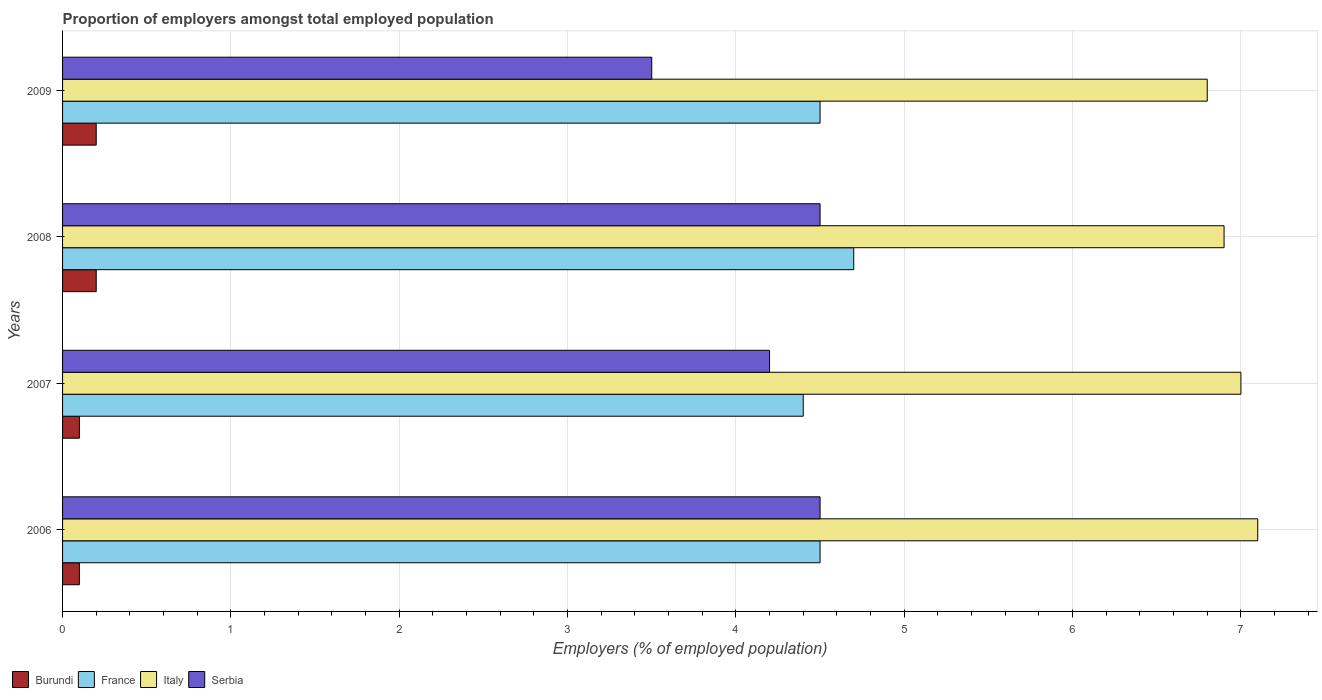Are the number of bars on each tick of the Y-axis equal?
Give a very brief answer. Yes. How many bars are there on the 2nd tick from the top?
Ensure brevity in your answer.  4. What is the label of the 2nd group of bars from the top?
Offer a terse response. 2008. What is the proportion of employers in Italy in 2009?
Your response must be concise. 6.8. Across all years, what is the maximum proportion of employers in Italy?
Ensure brevity in your answer.  7.1. Across all years, what is the minimum proportion of employers in Burundi?
Your response must be concise. 0.1. In which year was the proportion of employers in Burundi minimum?
Offer a very short reply. 2006. What is the total proportion of employers in Burundi in the graph?
Offer a terse response. 0.6. What is the difference between the proportion of employers in Burundi in 2007 and that in 2008?
Provide a short and direct response. -0.1. What is the difference between the proportion of employers in Italy in 2006 and the proportion of employers in Serbia in 2007?
Offer a terse response. 2.9. What is the average proportion of employers in Italy per year?
Offer a very short reply. 6.95. In the year 2007, what is the difference between the proportion of employers in France and proportion of employers in Italy?
Offer a very short reply. -2.6. In how many years, is the proportion of employers in Serbia greater than 0.6000000000000001 %?
Offer a terse response. 4. What is the ratio of the proportion of employers in Serbia in 2007 to that in 2009?
Your answer should be compact. 1.2. Is the proportion of employers in France in 2006 less than that in 2008?
Give a very brief answer. Yes. What is the difference between the highest and the second highest proportion of employers in France?
Offer a very short reply. 0.2. What is the difference between the highest and the lowest proportion of employers in Serbia?
Offer a terse response. 1. Is it the case that in every year, the sum of the proportion of employers in Serbia and proportion of employers in Burundi is greater than the sum of proportion of employers in France and proportion of employers in Italy?
Provide a short and direct response. No. What does the 4th bar from the top in 2008 represents?
Offer a terse response. Burundi. What does the 2nd bar from the bottom in 2007 represents?
Give a very brief answer. France. How many bars are there?
Provide a short and direct response. 16. Are all the bars in the graph horizontal?
Make the answer very short. Yes. How many years are there in the graph?
Offer a terse response. 4. Are the values on the major ticks of X-axis written in scientific E-notation?
Make the answer very short. No. How many legend labels are there?
Offer a very short reply. 4. What is the title of the graph?
Your response must be concise. Proportion of employers amongst total employed population. What is the label or title of the X-axis?
Give a very brief answer. Employers (% of employed population). What is the Employers (% of employed population) in Burundi in 2006?
Your answer should be very brief. 0.1. What is the Employers (% of employed population) of Italy in 2006?
Provide a short and direct response. 7.1. What is the Employers (% of employed population) in Serbia in 2006?
Give a very brief answer. 4.5. What is the Employers (% of employed population) in Burundi in 2007?
Your response must be concise. 0.1. What is the Employers (% of employed population) in France in 2007?
Your answer should be compact. 4.4. What is the Employers (% of employed population) in Serbia in 2007?
Your response must be concise. 4.2. What is the Employers (% of employed population) of Burundi in 2008?
Make the answer very short. 0.2. What is the Employers (% of employed population) in France in 2008?
Keep it short and to the point. 4.7. What is the Employers (% of employed population) of Italy in 2008?
Your response must be concise. 6.9. What is the Employers (% of employed population) in Burundi in 2009?
Provide a short and direct response. 0.2. What is the Employers (% of employed population) in Italy in 2009?
Give a very brief answer. 6.8. Across all years, what is the maximum Employers (% of employed population) of Burundi?
Ensure brevity in your answer.  0.2. Across all years, what is the maximum Employers (% of employed population) in France?
Provide a short and direct response. 4.7. Across all years, what is the maximum Employers (% of employed population) in Italy?
Your answer should be very brief. 7.1. Across all years, what is the maximum Employers (% of employed population) of Serbia?
Make the answer very short. 4.5. Across all years, what is the minimum Employers (% of employed population) in Burundi?
Your answer should be compact. 0.1. Across all years, what is the minimum Employers (% of employed population) in France?
Offer a very short reply. 4.4. Across all years, what is the minimum Employers (% of employed population) of Italy?
Keep it short and to the point. 6.8. What is the total Employers (% of employed population) of Burundi in the graph?
Provide a short and direct response. 0.6. What is the total Employers (% of employed population) in Italy in the graph?
Your answer should be compact. 27.8. What is the difference between the Employers (% of employed population) of Burundi in 2006 and that in 2007?
Make the answer very short. 0. What is the difference between the Employers (% of employed population) in Italy in 2006 and that in 2007?
Give a very brief answer. 0.1. What is the difference between the Employers (% of employed population) of Serbia in 2006 and that in 2007?
Provide a short and direct response. 0.3. What is the difference between the Employers (% of employed population) in France in 2006 and that in 2008?
Make the answer very short. -0.2. What is the difference between the Employers (% of employed population) of Serbia in 2006 and that in 2008?
Ensure brevity in your answer.  0. What is the difference between the Employers (% of employed population) of France in 2006 and that in 2009?
Offer a very short reply. 0. What is the difference between the Employers (% of employed population) in Italy in 2006 and that in 2009?
Your answer should be very brief. 0.3. What is the difference between the Employers (% of employed population) of Serbia in 2006 and that in 2009?
Make the answer very short. 1. What is the difference between the Employers (% of employed population) in Burundi in 2007 and that in 2008?
Keep it short and to the point. -0.1. What is the difference between the Employers (% of employed population) in Italy in 2007 and that in 2008?
Your answer should be very brief. 0.1. What is the difference between the Employers (% of employed population) in Serbia in 2007 and that in 2008?
Your answer should be very brief. -0.3. What is the difference between the Employers (% of employed population) in Serbia in 2008 and that in 2009?
Offer a terse response. 1. What is the difference between the Employers (% of employed population) of France in 2006 and the Employers (% of employed population) of Italy in 2007?
Provide a succinct answer. -2.5. What is the difference between the Employers (% of employed population) of Italy in 2006 and the Employers (% of employed population) of Serbia in 2007?
Provide a short and direct response. 2.9. What is the difference between the Employers (% of employed population) in Burundi in 2006 and the Employers (% of employed population) in France in 2008?
Provide a succinct answer. -4.6. What is the difference between the Employers (% of employed population) of Italy in 2006 and the Employers (% of employed population) of Serbia in 2008?
Your answer should be very brief. 2.6. What is the difference between the Employers (% of employed population) in Burundi in 2006 and the Employers (% of employed population) in France in 2009?
Your answer should be very brief. -4.4. What is the difference between the Employers (% of employed population) in Burundi in 2006 and the Employers (% of employed population) in Serbia in 2009?
Give a very brief answer. -3.4. What is the difference between the Employers (% of employed population) of France in 2006 and the Employers (% of employed population) of Serbia in 2009?
Make the answer very short. 1. What is the difference between the Employers (% of employed population) of France in 2007 and the Employers (% of employed population) of Serbia in 2008?
Provide a short and direct response. -0.1. What is the difference between the Employers (% of employed population) in Burundi in 2007 and the Employers (% of employed population) in France in 2009?
Offer a terse response. -4.4. What is the difference between the Employers (% of employed population) in France in 2007 and the Employers (% of employed population) in Serbia in 2009?
Ensure brevity in your answer.  0.9. What is the average Employers (% of employed population) in Burundi per year?
Your answer should be compact. 0.15. What is the average Employers (% of employed population) of France per year?
Provide a short and direct response. 4.53. What is the average Employers (% of employed population) in Italy per year?
Offer a very short reply. 6.95. What is the average Employers (% of employed population) of Serbia per year?
Ensure brevity in your answer.  4.17. In the year 2006, what is the difference between the Employers (% of employed population) of Burundi and Employers (% of employed population) of France?
Your answer should be compact. -4.4. In the year 2006, what is the difference between the Employers (% of employed population) of Burundi and Employers (% of employed population) of Italy?
Make the answer very short. -7. In the year 2006, what is the difference between the Employers (% of employed population) in Burundi and Employers (% of employed population) in Serbia?
Keep it short and to the point. -4.4. In the year 2006, what is the difference between the Employers (% of employed population) of France and Employers (% of employed population) of Italy?
Your response must be concise. -2.6. In the year 2006, what is the difference between the Employers (% of employed population) of France and Employers (% of employed population) of Serbia?
Provide a succinct answer. 0. In the year 2006, what is the difference between the Employers (% of employed population) in Italy and Employers (% of employed population) in Serbia?
Provide a succinct answer. 2.6. In the year 2007, what is the difference between the Employers (% of employed population) in Burundi and Employers (% of employed population) in Italy?
Give a very brief answer. -6.9. In the year 2007, what is the difference between the Employers (% of employed population) in Burundi and Employers (% of employed population) in Serbia?
Offer a very short reply. -4.1. In the year 2007, what is the difference between the Employers (% of employed population) of Italy and Employers (% of employed population) of Serbia?
Your response must be concise. 2.8. In the year 2008, what is the difference between the Employers (% of employed population) of Burundi and Employers (% of employed population) of France?
Keep it short and to the point. -4.5. In the year 2008, what is the difference between the Employers (% of employed population) of Burundi and Employers (% of employed population) of Italy?
Offer a terse response. -6.7. In the year 2008, what is the difference between the Employers (% of employed population) in Burundi and Employers (% of employed population) in Serbia?
Your answer should be very brief. -4.3. In the year 2008, what is the difference between the Employers (% of employed population) of France and Employers (% of employed population) of Italy?
Provide a short and direct response. -2.2. In the year 2009, what is the difference between the Employers (% of employed population) of Burundi and Employers (% of employed population) of Serbia?
Your response must be concise. -3.3. In the year 2009, what is the difference between the Employers (% of employed population) of France and Employers (% of employed population) of Serbia?
Offer a terse response. 1. What is the ratio of the Employers (% of employed population) in Burundi in 2006 to that in 2007?
Give a very brief answer. 1. What is the ratio of the Employers (% of employed population) in France in 2006 to that in 2007?
Offer a terse response. 1.02. What is the ratio of the Employers (% of employed population) of Italy in 2006 to that in 2007?
Give a very brief answer. 1.01. What is the ratio of the Employers (% of employed population) of Serbia in 2006 to that in 2007?
Your answer should be very brief. 1.07. What is the ratio of the Employers (% of employed population) in Burundi in 2006 to that in 2008?
Offer a very short reply. 0.5. What is the ratio of the Employers (% of employed population) in France in 2006 to that in 2008?
Make the answer very short. 0.96. What is the ratio of the Employers (% of employed population) of Serbia in 2006 to that in 2008?
Your answer should be compact. 1. What is the ratio of the Employers (% of employed population) in Burundi in 2006 to that in 2009?
Provide a short and direct response. 0.5. What is the ratio of the Employers (% of employed population) in Italy in 2006 to that in 2009?
Provide a succinct answer. 1.04. What is the ratio of the Employers (% of employed population) of Burundi in 2007 to that in 2008?
Your response must be concise. 0.5. What is the ratio of the Employers (% of employed population) in France in 2007 to that in 2008?
Your answer should be compact. 0.94. What is the ratio of the Employers (% of employed population) in Italy in 2007 to that in 2008?
Offer a very short reply. 1.01. What is the ratio of the Employers (% of employed population) of France in 2007 to that in 2009?
Ensure brevity in your answer.  0.98. What is the ratio of the Employers (% of employed population) of Italy in 2007 to that in 2009?
Your answer should be very brief. 1.03. What is the ratio of the Employers (% of employed population) in Serbia in 2007 to that in 2009?
Ensure brevity in your answer.  1.2. What is the ratio of the Employers (% of employed population) of France in 2008 to that in 2009?
Your answer should be very brief. 1.04. What is the ratio of the Employers (% of employed population) in Italy in 2008 to that in 2009?
Your response must be concise. 1.01. What is the difference between the highest and the second highest Employers (% of employed population) in Burundi?
Make the answer very short. 0. What is the difference between the highest and the second highest Employers (% of employed population) of France?
Keep it short and to the point. 0.2. What is the difference between the highest and the second highest Employers (% of employed population) of Italy?
Keep it short and to the point. 0.1. What is the difference between the highest and the second highest Employers (% of employed population) of Serbia?
Your answer should be compact. 0. What is the difference between the highest and the lowest Employers (% of employed population) in Burundi?
Ensure brevity in your answer.  0.1. What is the difference between the highest and the lowest Employers (% of employed population) in France?
Your answer should be compact. 0.3. What is the difference between the highest and the lowest Employers (% of employed population) of Italy?
Provide a short and direct response. 0.3. 